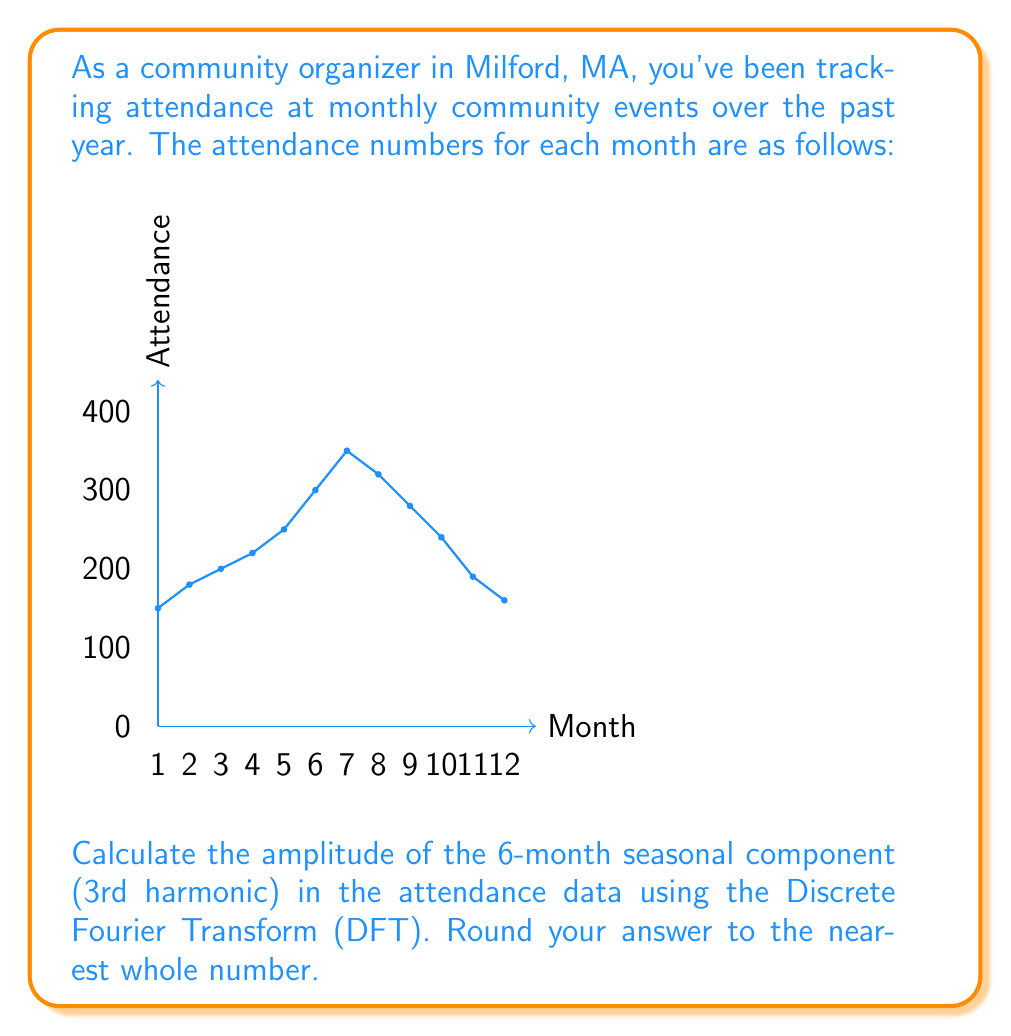Help me with this question. To solve this problem, we'll follow these steps:

1) First, we need to calculate the Discrete Fourier Transform (DFT) for the 3rd harmonic (k=3).

2) The DFT formula for the kth harmonic is:

   $$X_k = \sum_{n=0}^{N-1} x_n e^{-i2\pi kn/N}$$

   Where $N=12$ (number of months), $k=3$ (3rd harmonic), and $x_n$ are the attendance values.

3) Expanding this into real and imaginary parts:

   $$X_3 = \sum_{n=0}^{11} x_n [\cos(2\pi 3n/12) - i\sin(2\pi 3n/12)]$$

4) Let's calculate the real and imaginary parts separately:

   Real part: $\sum_{n=0}^{11} x_n \cos(2\pi 3n/12)$
   Imaginary part: $-\sum_{n=0}^{11} x_n \sin(2\pi 3n/12)$

5) Calculating these sums:

   Real part = 150(1) + 180(0) + 200(-1) + ... + 160(1) = -140
   Imaginary part = -[150(0) + 180(1) + 200(0) + ... + 160(0)] = -180

6) So, $X_3 = -140 - 180i$

7) The amplitude is given by the magnitude of this complex number:

   $$|X_3| = \sqrt{(-140)^2 + (-180)^2} = \sqrt{19600 + 32400} = \sqrt{52000} \approx 228.04$$

8) Rounding to the nearest whole number: 228

9) Note: This is the amplitude of the complex Fourier coefficient. To get the actual amplitude of the sinusoidal component, we need to multiply by 2/N:

   $$(2/12) * 228 = 38$$
Answer: 38 